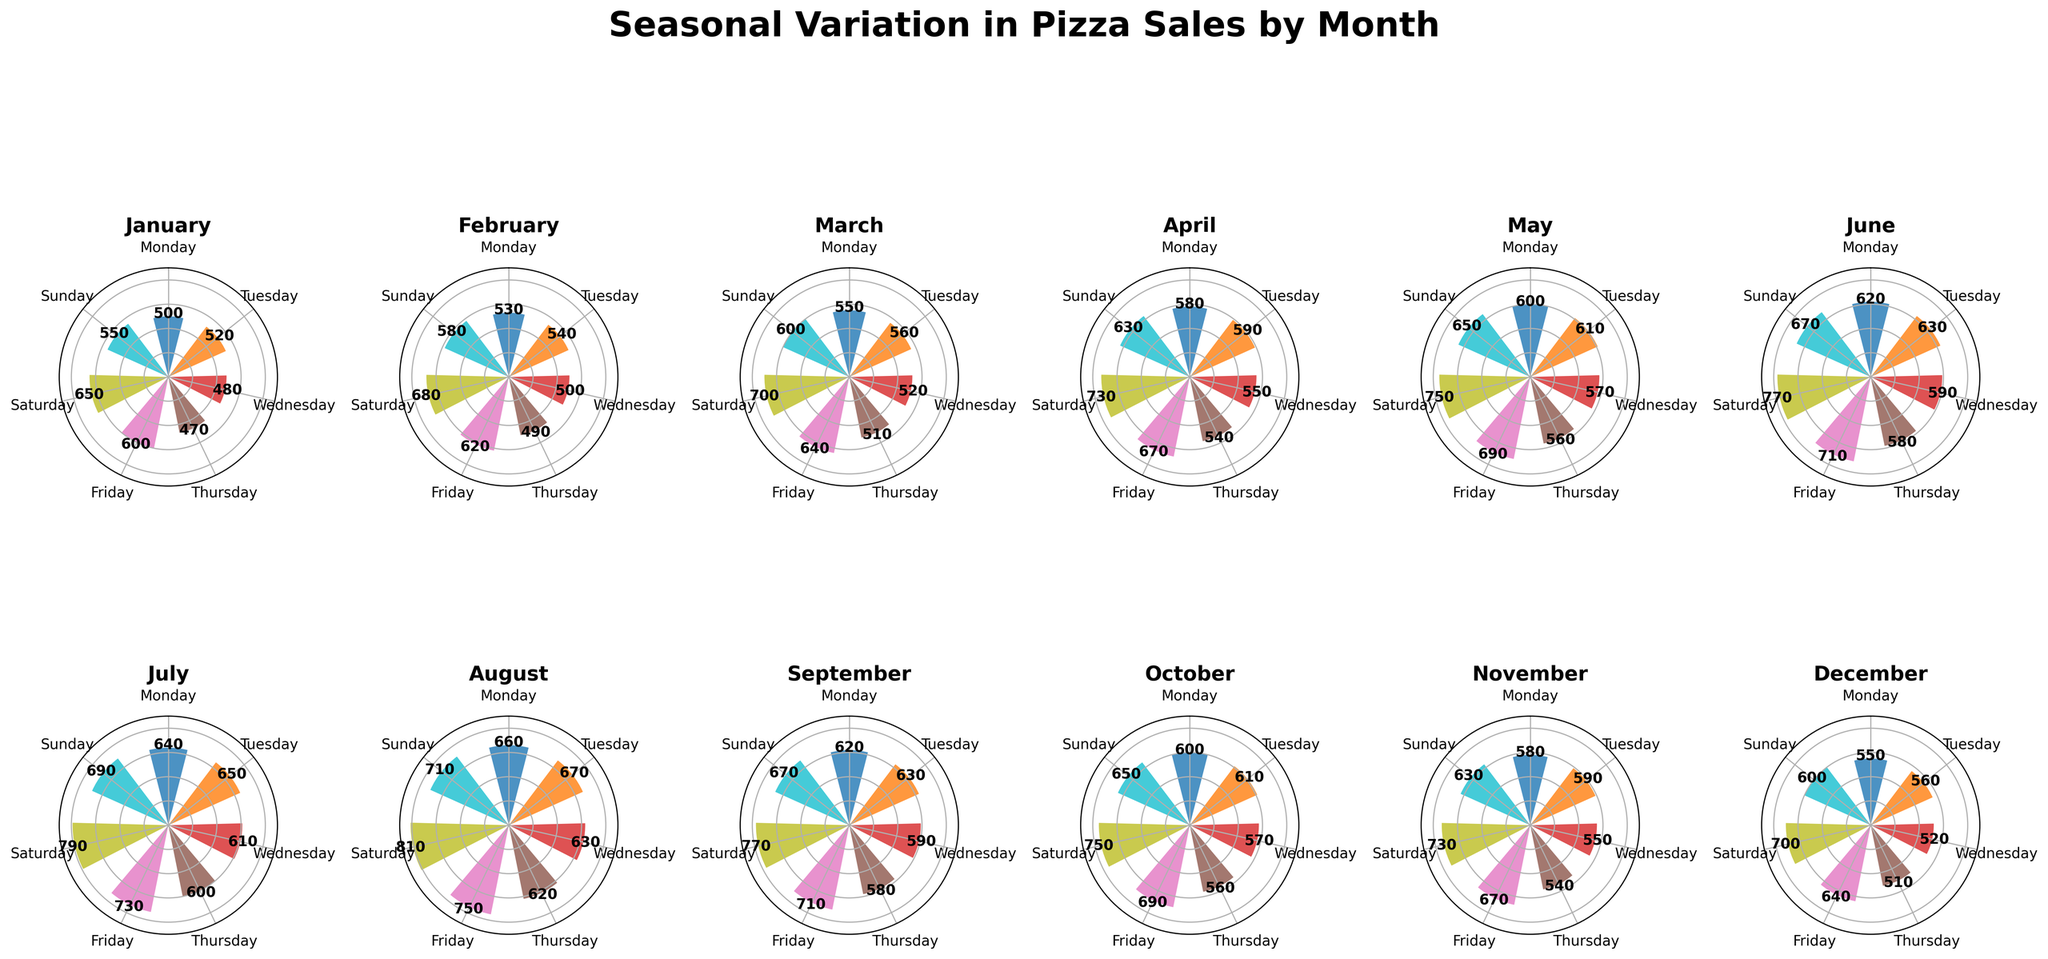What is the title of the figure? The title is displayed at the top center of the figure. It reads 'Seasonal Variation in Pizza Sales by Month'.
Answer: Seasonal Variation in Pizza Sales by Month Which month has the highest sales on Saturdays? By looking at the bars representing Saturday sales in each month's polar subplot, the tallest bar for Saturday appears in August.
Answer: August What is the average sales on Fridays for the months of July and August? Add the sales on Fridays for July (730) and August (750) and divide by 2. (730 + 750) / 2 = 740
Answer: 740 Compare the sales on Mondays and fund the month with the most significant difference in sales between Monday and Friday. What is that difference? Check the difference in sales for each Monday and Friday in each month. August has 660 on Monday and 750 on Friday, the difference is 90, which is the largest difference.
Answer: August, 90 Which month shows the lowest sales on Wednesdays? By identifying the shortest bars for Wednesdays in each month’s subplot, January has the lowest Wednesday sales at 480.
Answer: January What is the average of the highest sales day across all months? Identify the highest sales day for each month and average them: Jan (650), Feb (680), Mar (700), Apr (730), May (750), Jun (770), Jul (790), Aug (810), Sep (770), Oct (750), Nov (730), Dec (700). Average: (650+680+700+730+750+770+790+810+770+750+730+700) / 12 = 732.5
Answer: 732.5 If sales on Sundays were to increase by 10% in December, what would be the new value? The current sales on Sundays in December is 600. Increasing by 10% means 600 * 0.10 = 60. Therefore, the new sales value would be 600 + 60 = 660.
Answer: 660 What's the ratio of sales on Wednesdays to Fridays in March? Sales on Wednesday in March is 520, and on Friday is 640. The ratio is 520/640 = 0.8125.
Answer: 0.8125 Which month has consistently increasing sales throughout the week? Observe the patterns of increasing sales from Monday to Sunday. August shows consistently increasing sales from 660 on Monday to 810 on Saturday and 710 on Sunday.
Answer: August What is the median sales value for Thursdays across all months? Collect sales values for Thursdays: [470, 490, 510, 540, 560, 580, 600, 620, 580, 560, 540, 510]. Arrange and find the middle value(s): 540, 540, 560, 560, 580, 580, 600, 510, 510, 470, 490. The median is (560 + 580) / 2 = 570.
Answer: 570 